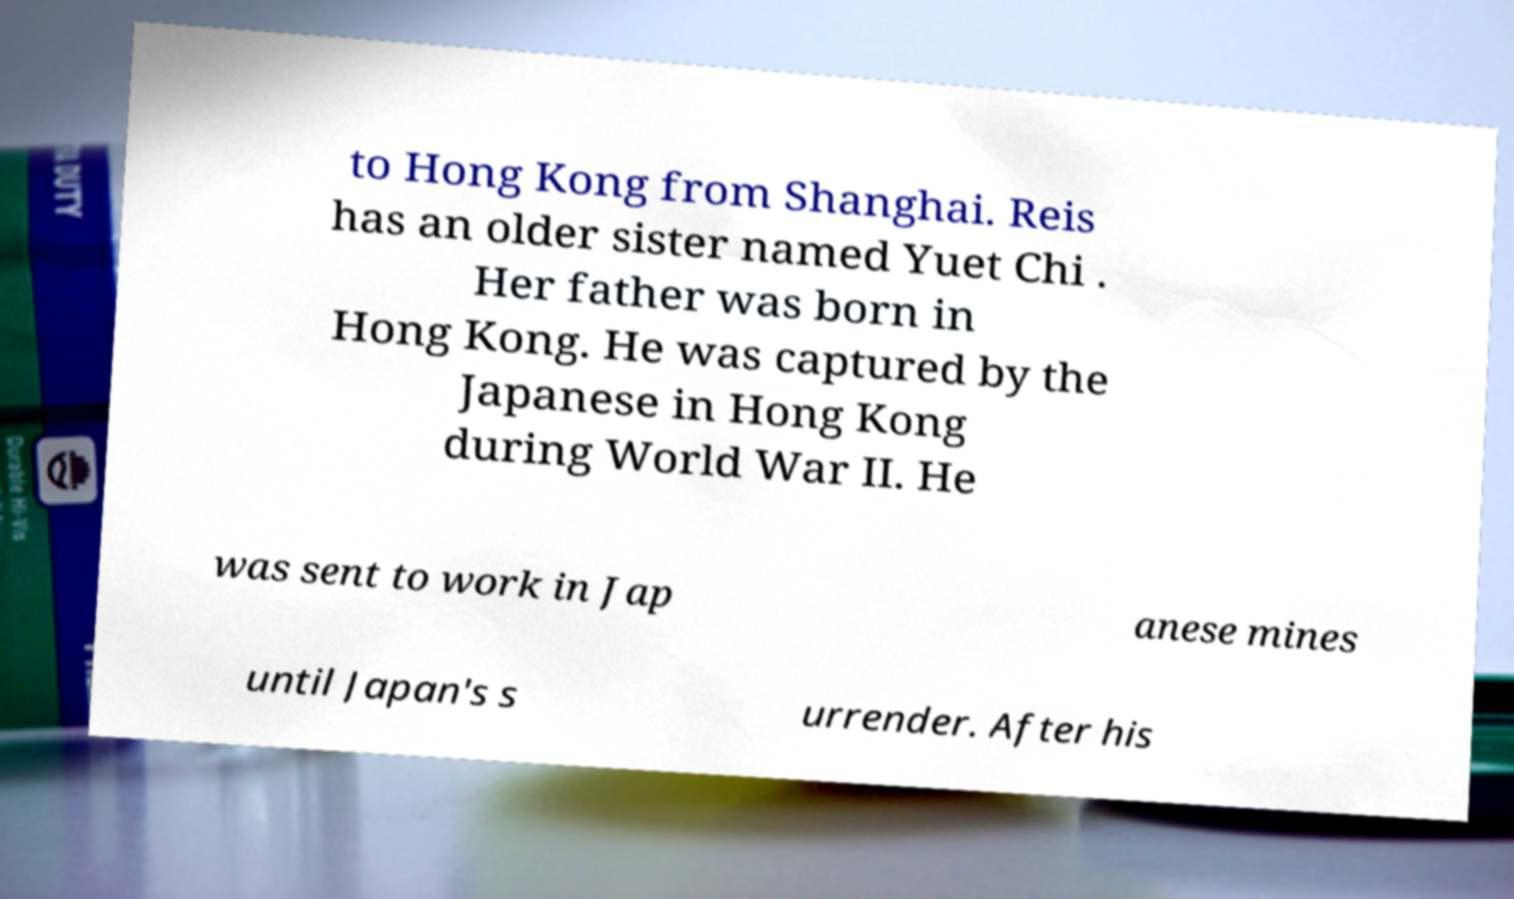Could you extract and type out the text from this image? to Hong Kong from Shanghai. Reis has an older sister named Yuet Chi . Her father was born in Hong Kong. He was captured by the Japanese in Hong Kong during World War II. He was sent to work in Jap anese mines until Japan's s urrender. After his 